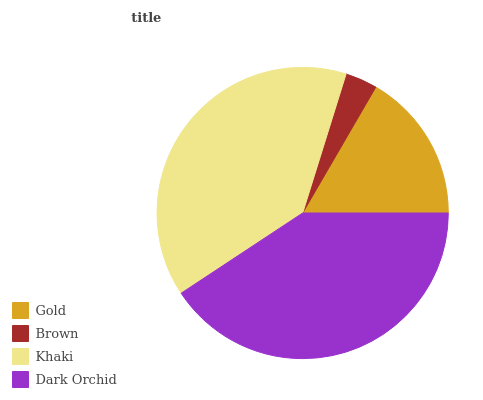Is Brown the minimum?
Answer yes or no. Yes. Is Dark Orchid the maximum?
Answer yes or no. Yes. Is Khaki the minimum?
Answer yes or no. No. Is Khaki the maximum?
Answer yes or no. No. Is Khaki greater than Brown?
Answer yes or no. Yes. Is Brown less than Khaki?
Answer yes or no. Yes. Is Brown greater than Khaki?
Answer yes or no. No. Is Khaki less than Brown?
Answer yes or no. No. Is Khaki the high median?
Answer yes or no. Yes. Is Gold the low median?
Answer yes or no. Yes. Is Brown the high median?
Answer yes or no. No. Is Khaki the low median?
Answer yes or no. No. 